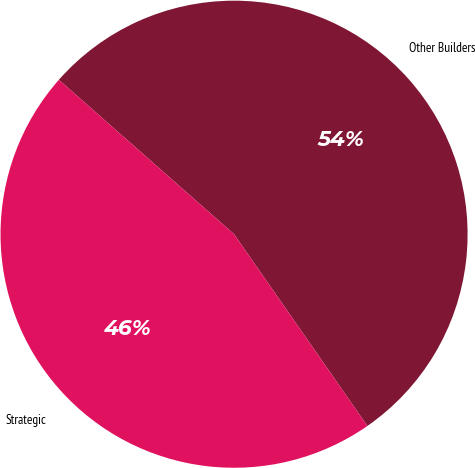Convert chart. <chart><loc_0><loc_0><loc_500><loc_500><pie_chart><fcel>Other Builders<fcel>Strategic<nl><fcel>53.83%<fcel>46.17%<nl></chart> 